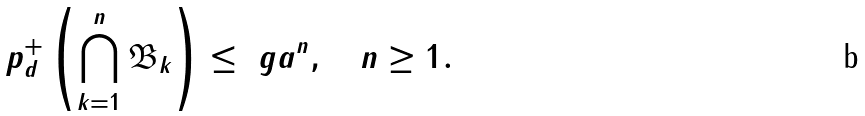<formula> <loc_0><loc_0><loc_500><loc_500>p _ { d } ^ { + } \left ( \bigcap _ { k = 1 } ^ { n } \mathfrak B _ { k } \right ) \leq \ g a ^ { n } , \quad n \geq 1 .</formula> 